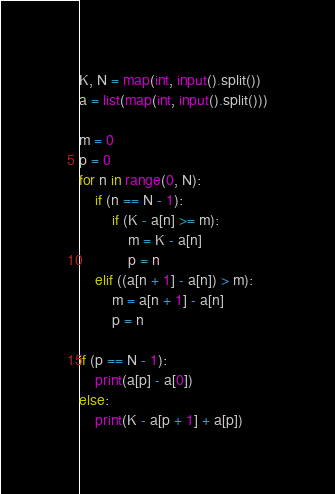Convert code to text. <code><loc_0><loc_0><loc_500><loc_500><_Python_>K, N = map(int, input().split())
a = list(map(int, input().split()))

m = 0
p = 0
for n in range(0, N):
    if (n == N - 1):
        if (K - a[n] >= m):
            m = K - a[n]
            p = n
    elif ((a[n + 1] - a[n]) > m):
        m = a[n + 1] - a[n]
        p = n

if (p == N - 1):
    print(a[p] - a[0])
else:
    print(K - a[p + 1] + a[p])</code> 